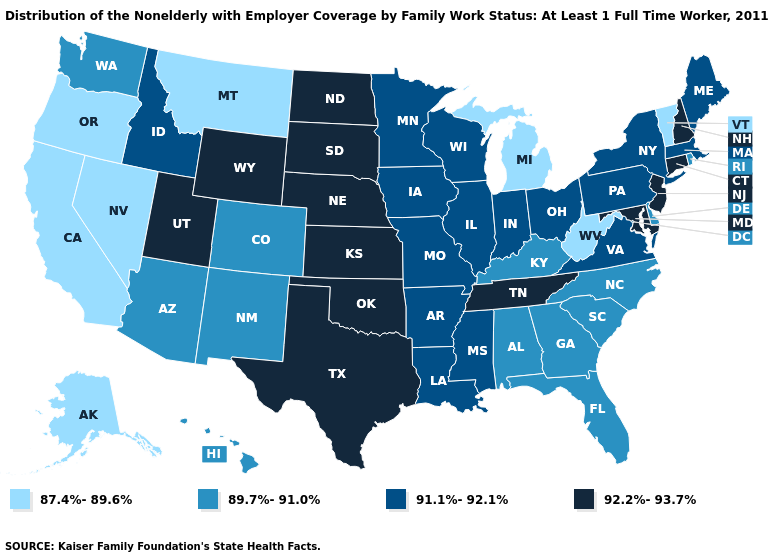What is the lowest value in states that border Colorado?
Answer briefly. 89.7%-91.0%. Does Texas have the lowest value in the South?
Give a very brief answer. No. What is the value of North Carolina?
Be succinct. 89.7%-91.0%. What is the value of Arizona?
Be succinct. 89.7%-91.0%. Which states hav the highest value in the South?
Give a very brief answer. Maryland, Oklahoma, Tennessee, Texas. Name the states that have a value in the range 92.2%-93.7%?
Be succinct. Connecticut, Kansas, Maryland, Nebraska, New Hampshire, New Jersey, North Dakota, Oklahoma, South Dakota, Tennessee, Texas, Utah, Wyoming. Name the states that have a value in the range 89.7%-91.0%?
Be succinct. Alabama, Arizona, Colorado, Delaware, Florida, Georgia, Hawaii, Kentucky, New Mexico, North Carolina, Rhode Island, South Carolina, Washington. Name the states that have a value in the range 92.2%-93.7%?
Keep it brief. Connecticut, Kansas, Maryland, Nebraska, New Hampshire, New Jersey, North Dakota, Oklahoma, South Dakota, Tennessee, Texas, Utah, Wyoming. How many symbols are there in the legend?
Be succinct. 4. Name the states that have a value in the range 91.1%-92.1%?
Short answer required. Arkansas, Idaho, Illinois, Indiana, Iowa, Louisiana, Maine, Massachusetts, Minnesota, Mississippi, Missouri, New York, Ohio, Pennsylvania, Virginia, Wisconsin. Among the states that border Arkansas , which have the highest value?
Write a very short answer. Oklahoma, Tennessee, Texas. Name the states that have a value in the range 89.7%-91.0%?
Concise answer only. Alabama, Arizona, Colorado, Delaware, Florida, Georgia, Hawaii, Kentucky, New Mexico, North Carolina, Rhode Island, South Carolina, Washington. What is the value of Ohio?
Be succinct. 91.1%-92.1%. Name the states that have a value in the range 89.7%-91.0%?
Concise answer only. Alabama, Arizona, Colorado, Delaware, Florida, Georgia, Hawaii, Kentucky, New Mexico, North Carolina, Rhode Island, South Carolina, Washington. 